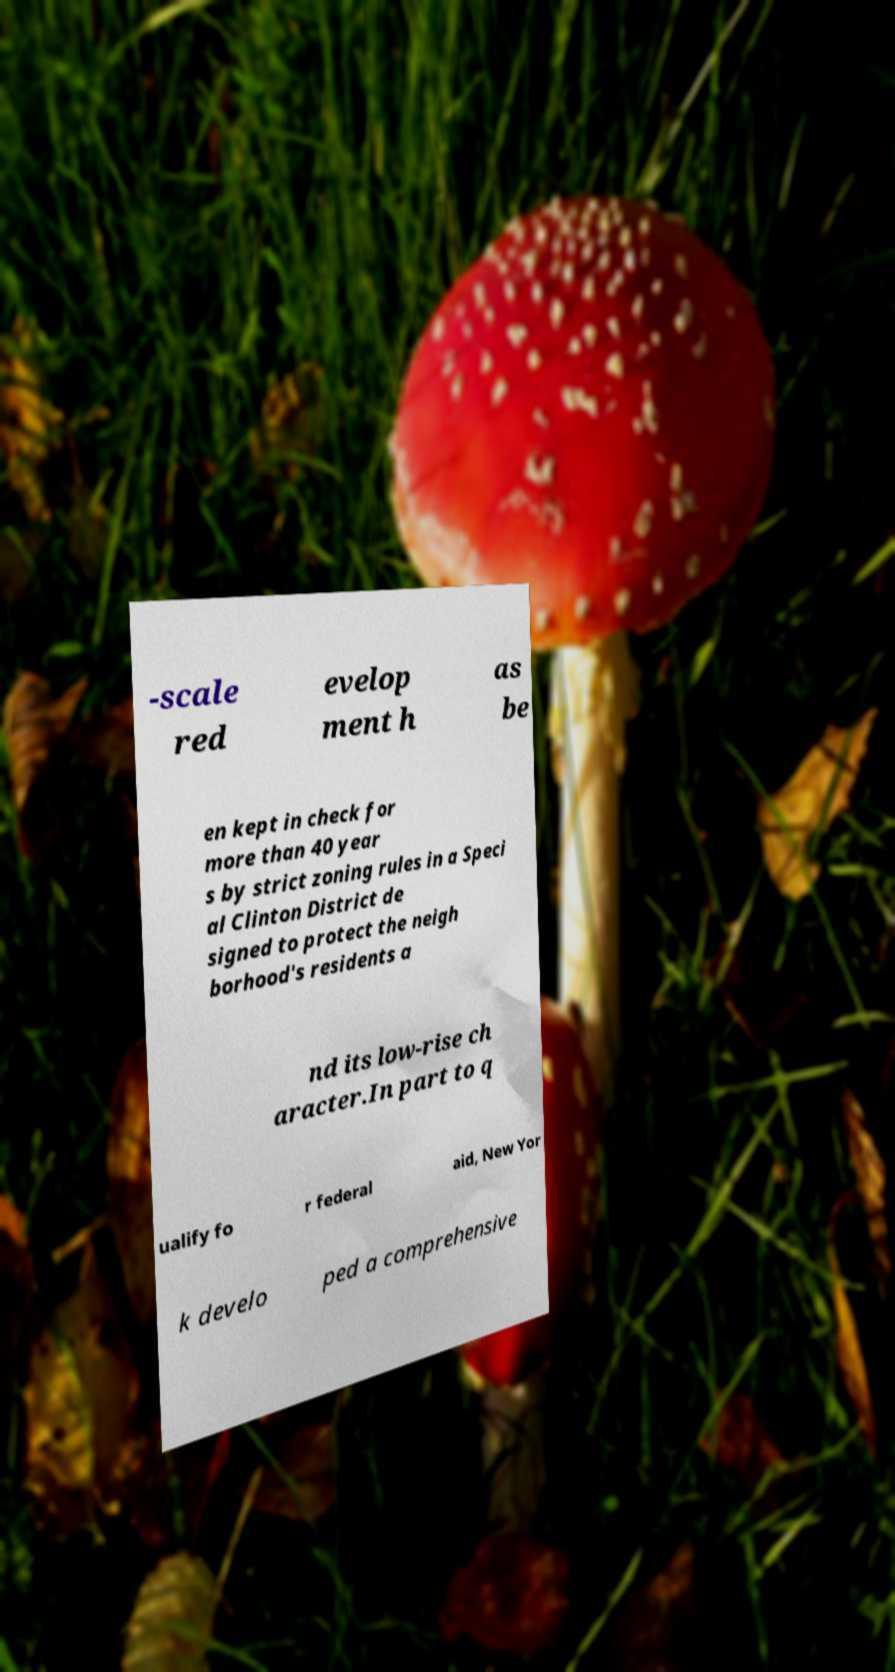There's text embedded in this image that I need extracted. Can you transcribe it verbatim? -scale red evelop ment h as be en kept in check for more than 40 year s by strict zoning rules in a Speci al Clinton District de signed to protect the neigh borhood's residents a nd its low-rise ch aracter.In part to q ualify fo r federal aid, New Yor k develo ped a comprehensive 